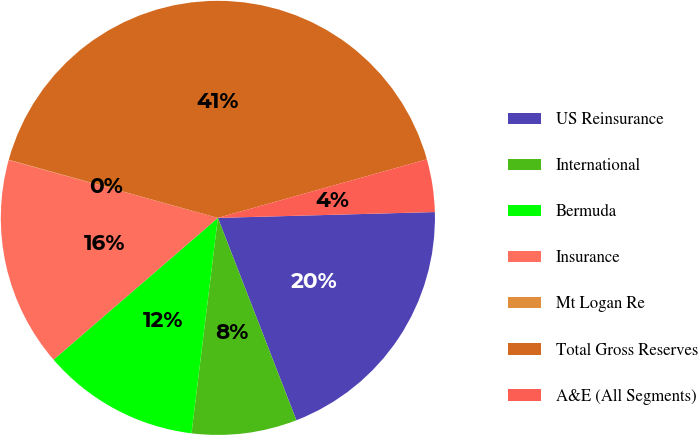Convert chart. <chart><loc_0><loc_0><loc_500><loc_500><pie_chart><fcel>US Reinsurance<fcel>International<fcel>Bermuda<fcel>Insurance<fcel>Mt Logan Re<fcel>Total Gross Reserves<fcel>A&E (All Segments)<nl><fcel>19.54%<fcel>7.83%<fcel>11.73%<fcel>15.63%<fcel>0.02%<fcel>41.34%<fcel>3.92%<nl></chart> 